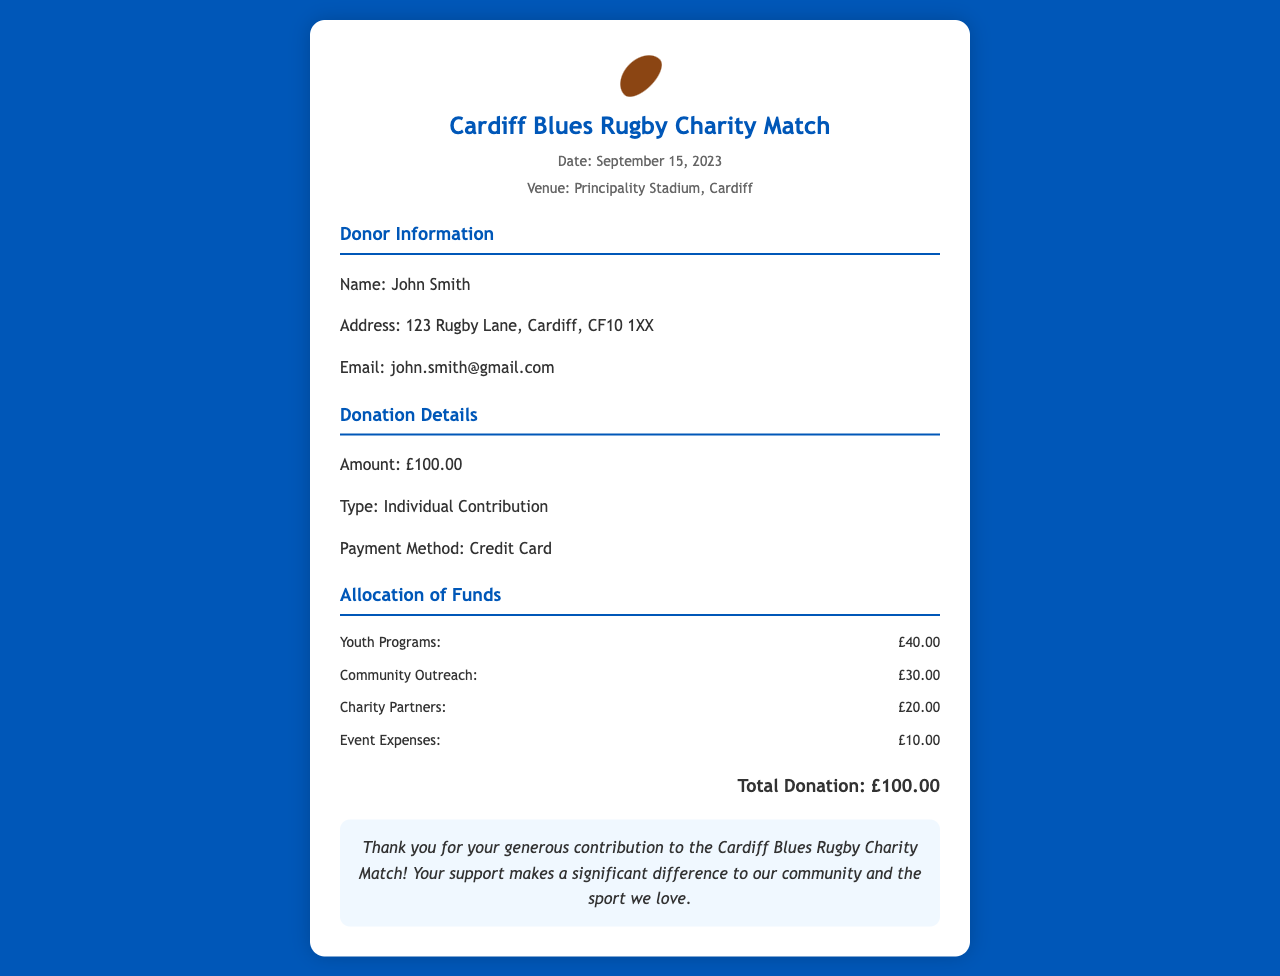What is the donor's name? The donor's name is listed under the Donor Information section of the document.
Answer: John Smith What is the date of the charity match? The date of the charity match is indicated in the header of the receipt.
Answer: September 15, 2023 What was the total donation amount? The total donation amount is presented at the end of the Allocation of Funds section.
Answer: £100.00 How much was allocated to Youth Programs? The amount allocated to Youth Programs is specified in the Allocation of Funds section.
Answer: £40.00 What payment method was used for the donation? The payment method is mentioned in the Donation Details section.
Answer: Credit Card How much was allocated to Event Expenses? The allocation for Event Expenses is detailed under the Allocation of Funds section.
Answer: £10.00 What percentage of the total donation went to Community Outreach? To determine this, you would take the allocation for Community Outreach (£30.00) and compare it to the total donation (£100.00).
Answer: 30% What type of contribution was made? The type of contribution is stated in the Donation Details section of the receipt.
Answer: Individual Contribution What is the venue of the charity match? The venue is listed in the header of the receipt.
Answer: Principality Stadium, Cardiff 